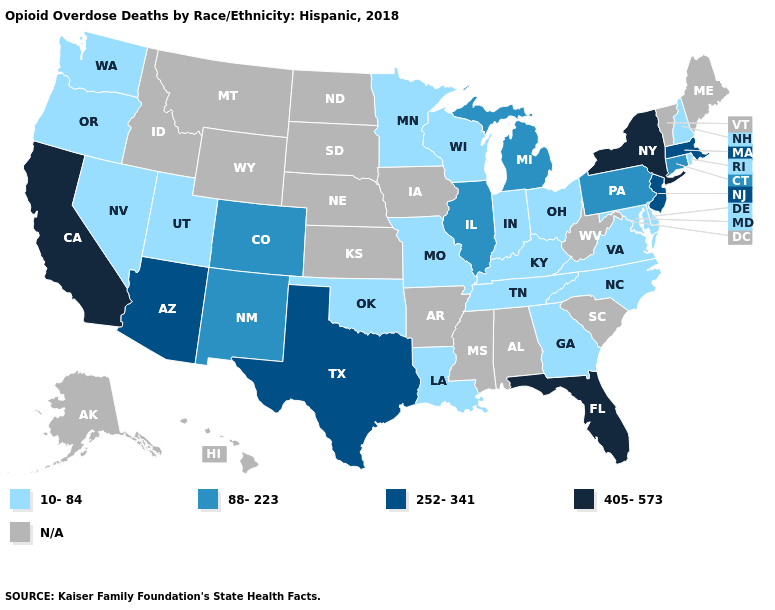What is the highest value in states that border Washington?
Quick response, please. 10-84. Name the states that have a value in the range N/A?
Answer briefly. Alabama, Alaska, Arkansas, Hawaii, Idaho, Iowa, Kansas, Maine, Mississippi, Montana, Nebraska, North Dakota, South Carolina, South Dakota, Vermont, West Virginia, Wyoming. Among the states that border South Carolina , which have the highest value?
Keep it brief. Georgia, North Carolina. What is the value of New York?
Write a very short answer. 405-573. Which states hav the highest value in the Northeast?
Give a very brief answer. New York. What is the value of Wisconsin?
Be succinct. 10-84. Does Delaware have the highest value in the USA?
Be succinct. No. Name the states that have a value in the range 10-84?
Give a very brief answer. Delaware, Georgia, Indiana, Kentucky, Louisiana, Maryland, Minnesota, Missouri, Nevada, New Hampshire, North Carolina, Ohio, Oklahoma, Oregon, Rhode Island, Tennessee, Utah, Virginia, Washington, Wisconsin. What is the lowest value in the Northeast?
Quick response, please. 10-84. What is the value of Tennessee?
Answer briefly. 10-84. Name the states that have a value in the range 252-341?
Be succinct. Arizona, Massachusetts, New Jersey, Texas. What is the highest value in the USA?
Short answer required. 405-573. What is the lowest value in states that border Texas?
Be succinct. 10-84. What is the value of Louisiana?
Concise answer only. 10-84. 